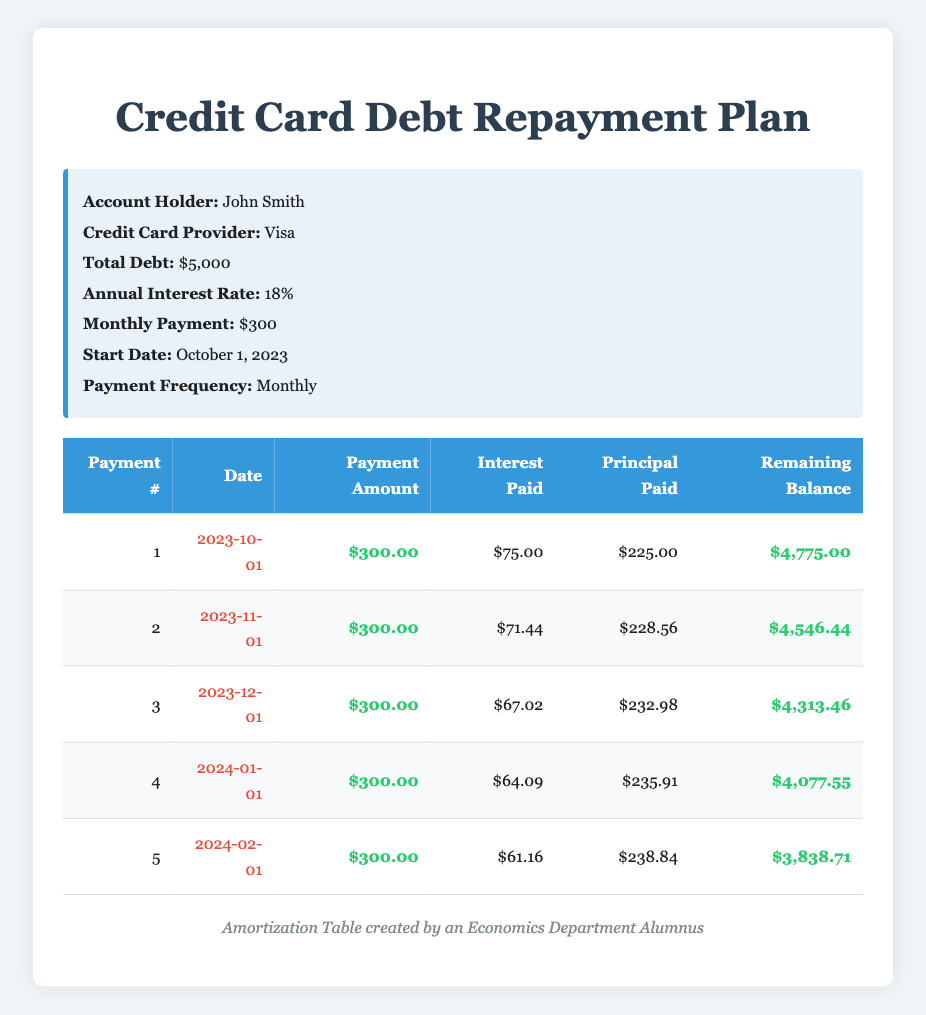What is the total initial debt of John Smith? The table states that the total debt under the credit card repayment plan is $5,000. Therefore, the initial debt amount is taken directly from the data provided.
Answer: 5000 How much interest was paid in the first payment? The table indicates that the interest paid during the first payment number is $75. This value is listed directly in the second column of the first row.
Answer: 75 What is the remaining balance after the second payment? According to the table, after the second payment on November 1, 2023, the remaining balance is $4,546.44. This balance is shown in the last column for the second payment row.
Answer: 4546.44 How much total principal has been paid off after the first three payments? The principal paid during the first three payments is $225 (first payment) + $228.56 (second payment) + $232.98 (third payment) = $686.54. This is calculated by summing the principal amounts across the first three rows.
Answer: 686.54 Is the interest paid in the fourth payment less than in the first payment? The interest paid in the first payment was $75 and in the fourth payment it is $64.09. Since $64.09 is less than $75, this statement is true.
Answer: Yes What is the average monthly principal paid across the first five payments? The total principal paid across the five payments is $225 + $228.56 + $232.98 + $235.91 + $238.84 = $1151.29. To find the average, divide this total by 5: $1151.29 / 5 = $230.258. Thus, the average principal paid is $230.258.
Answer: 230.26 What is the difference in interest paid between the first and fifth payments? The interest paid in the first payment is $75, and in the fifth payment, it is $61.16. The difference is $75 - $61.16 = $13.84. This is the result of subtracting the two interest amounts to find how much less was paid in the fifth payment.
Answer: 13.84 How many payments have been made by March 2024? The repayment plan starts on October 1, 2023, and goes monthly. By March 2024, five payments will have been made (October through February). This count is based on the number of completed rows in the table, each representing a payment.
Answer: 5 What is the total amount paid by the end of the fifth payment? Each payment amount is $300, so after five payments: 5 payments * $300 = $1500. This total is found by multiplying the number of payments by the payment amount.
Answer: 1500 